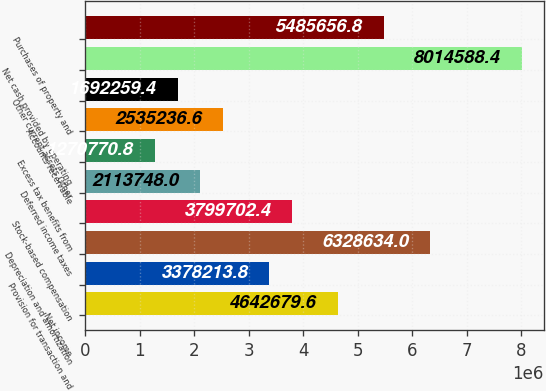Convert chart to OTSL. <chart><loc_0><loc_0><loc_500><loc_500><bar_chart><fcel>Net income<fcel>Provision for transaction and<fcel>Depreciation and amortization<fcel>Stock-based compensation<fcel>Deferred income taxes<fcel>Excess tax benefits from<fcel>Accounts receivable<fcel>Other current assets Other<fcel>Net cash provided by operating<fcel>Purchases of property and<nl><fcel>4.64268e+06<fcel>3.37821e+06<fcel>6.32863e+06<fcel>3.7997e+06<fcel>2.11375e+06<fcel>1.27077e+06<fcel>2.53524e+06<fcel>1.69226e+06<fcel>8.01459e+06<fcel>5.48566e+06<nl></chart> 